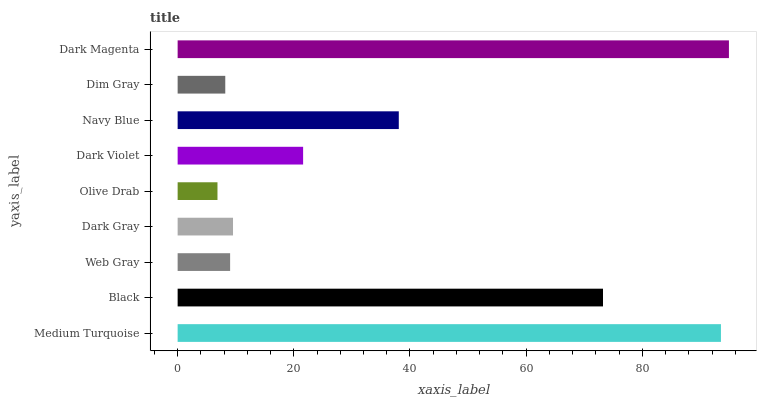Is Olive Drab the minimum?
Answer yes or no. Yes. Is Dark Magenta the maximum?
Answer yes or no. Yes. Is Black the minimum?
Answer yes or no. No. Is Black the maximum?
Answer yes or no. No. Is Medium Turquoise greater than Black?
Answer yes or no. Yes. Is Black less than Medium Turquoise?
Answer yes or no. Yes. Is Black greater than Medium Turquoise?
Answer yes or no. No. Is Medium Turquoise less than Black?
Answer yes or no. No. Is Dark Violet the high median?
Answer yes or no. Yes. Is Dark Violet the low median?
Answer yes or no. Yes. Is Olive Drab the high median?
Answer yes or no. No. Is Black the low median?
Answer yes or no. No. 